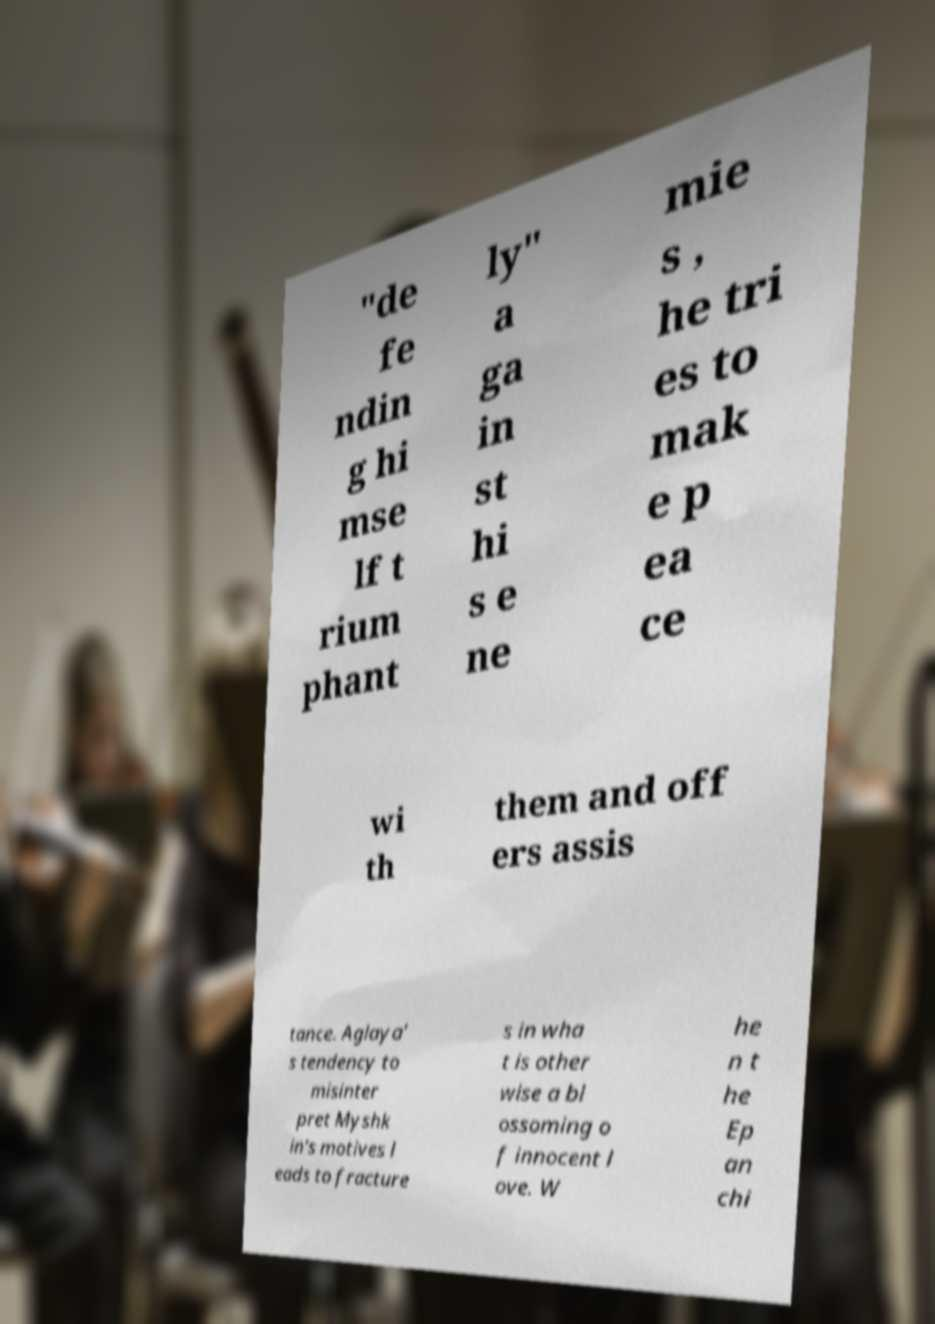What messages or text are displayed in this image? I need them in a readable, typed format. "de fe ndin g hi mse lf t rium phant ly" a ga in st hi s e ne mie s , he tri es to mak e p ea ce wi th them and off ers assis tance. Aglaya' s tendency to misinter pret Myshk in's motives l eads to fracture s in wha t is other wise a bl ossoming o f innocent l ove. W he n t he Ep an chi 